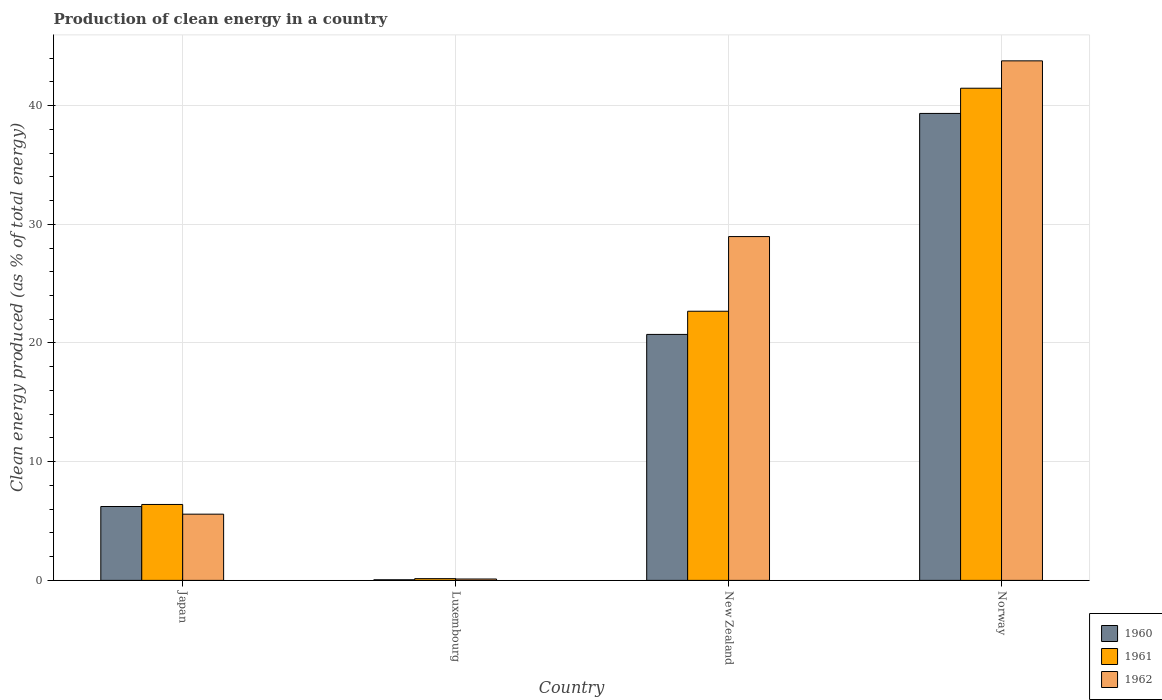Are the number of bars per tick equal to the number of legend labels?
Keep it short and to the point. Yes. Are the number of bars on each tick of the X-axis equal?
Provide a succinct answer. Yes. How many bars are there on the 3rd tick from the left?
Offer a terse response. 3. How many bars are there on the 3rd tick from the right?
Provide a succinct answer. 3. What is the label of the 1st group of bars from the left?
Provide a succinct answer. Japan. What is the percentage of clean energy produced in 1962 in Norway?
Your answer should be compact. 43.77. Across all countries, what is the maximum percentage of clean energy produced in 1961?
Offer a terse response. 41.46. Across all countries, what is the minimum percentage of clean energy produced in 1962?
Your answer should be very brief. 0.12. In which country was the percentage of clean energy produced in 1962 maximum?
Offer a very short reply. Norway. In which country was the percentage of clean energy produced in 1960 minimum?
Provide a short and direct response. Luxembourg. What is the total percentage of clean energy produced in 1961 in the graph?
Provide a short and direct response. 70.68. What is the difference between the percentage of clean energy produced in 1962 in Luxembourg and that in New Zealand?
Provide a succinct answer. -28.85. What is the difference between the percentage of clean energy produced in 1961 in Japan and the percentage of clean energy produced in 1962 in Norway?
Your answer should be compact. -37.37. What is the average percentage of clean energy produced in 1961 per country?
Your response must be concise. 17.67. What is the difference between the percentage of clean energy produced of/in 1960 and percentage of clean energy produced of/in 1962 in Luxembourg?
Provide a succinct answer. -0.06. What is the ratio of the percentage of clean energy produced in 1960 in Luxembourg to that in Norway?
Give a very brief answer. 0. Is the difference between the percentage of clean energy produced in 1960 in Luxembourg and New Zealand greater than the difference between the percentage of clean energy produced in 1962 in Luxembourg and New Zealand?
Keep it short and to the point. Yes. What is the difference between the highest and the second highest percentage of clean energy produced in 1960?
Your response must be concise. 14.5. What is the difference between the highest and the lowest percentage of clean energy produced in 1962?
Keep it short and to the point. 43.65. Is the sum of the percentage of clean energy produced in 1962 in New Zealand and Norway greater than the maximum percentage of clean energy produced in 1960 across all countries?
Keep it short and to the point. Yes. What does the 1st bar from the right in Norway represents?
Your answer should be compact. 1962. How many bars are there?
Offer a terse response. 12. How many countries are there in the graph?
Offer a terse response. 4. Are the values on the major ticks of Y-axis written in scientific E-notation?
Offer a terse response. No. Does the graph contain any zero values?
Give a very brief answer. No. Does the graph contain grids?
Ensure brevity in your answer.  Yes. How many legend labels are there?
Your response must be concise. 3. What is the title of the graph?
Offer a very short reply. Production of clean energy in a country. Does "2010" appear as one of the legend labels in the graph?
Provide a succinct answer. No. What is the label or title of the X-axis?
Ensure brevity in your answer.  Country. What is the label or title of the Y-axis?
Make the answer very short. Clean energy produced (as % of total energy). What is the Clean energy produced (as % of total energy) in 1960 in Japan?
Your answer should be very brief. 6.22. What is the Clean energy produced (as % of total energy) in 1961 in Japan?
Keep it short and to the point. 6.4. What is the Clean energy produced (as % of total energy) in 1962 in Japan?
Offer a very short reply. 5.58. What is the Clean energy produced (as % of total energy) of 1960 in Luxembourg?
Give a very brief answer. 0.05. What is the Clean energy produced (as % of total energy) of 1961 in Luxembourg?
Provide a short and direct response. 0.15. What is the Clean energy produced (as % of total energy) of 1962 in Luxembourg?
Your response must be concise. 0.12. What is the Clean energy produced (as % of total energy) in 1960 in New Zealand?
Your response must be concise. 20.72. What is the Clean energy produced (as % of total energy) in 1961 in New Zealand?
Offer a terse response. 22.67. What is the Clean energy produced (as % of total energy) of 1962 in New Zealand?
Keep it short and to the point. 28.96. What is the Clean energy produced (as % of total energy) in 1960 in Norway?
Ensure brevity in your answer.  39.34. What is the Clean energy produced (as % of total energy) in 1961 in Norway?
Keep it short and to the point. 41.46. What is the Clean energy produced (as % of total energy) in 1962 in Norway?
Ensure brevity in your answer.  43.77. Across all countries, what is the maximum Clean energy produced (as % of total energy) of 1960?
Your answer should be compact. 39.34. Across all countries, what is the maximum Clean energy produced (as % of total energy) of 1961?
Offer a very short reply. 41.46. Across all countries, what is the maximum Clean energy produced (as % of total energy) in 1962?
Provide a succinct answer. 43.77. Across all countries, what is the minimum Clean energy produced (as % of total energy) of 1960?
Provide a short and direct response. 0.05. Across all countries, what is the minimum Clean energy produced (as % of total energy) of 1961?
Provide a succinct answer. 0.15. Across all countries, what is the minimum Clean energy produced (as % of total energy) of 1962?
Your answer should be compact. 0.12. What is the total Clean energy produced (as % of total energy) of 1960 in the graph?
Your response must be concise. 66.33. What is the total Clean energy produced (as % of total energy) of 1961 in the graph?
Your answer should be compact. 70.68. What is the total Clean energy produced (as % of total energy) in 1962 in the graph?
Your answer should be compact. 78.42. What is the difference between the Clean energy produced (as % of total energy) of 1960 in Japan and that in Luxembourg?
Your response must be concise. 6.17. What is the difference between the Clean energy produced (as % of total energy) of 1961 in Japan and that in Luxembourg?
Provide a succinct answer. 6.25. What is the difference between the Clean energy produced (as % of total energy) of 1962 in Japan and that in Luxembourg?
Keep it short and to the point. 5.46. What is the difference between the Clean energy produced (as % of total energy) of 1960 in Japan and that in New Zealand?
Your response must be concise. -14.5. What is the difference between the Clean energy produced (as % of total energy) in 1961 in Japan and that in New Zealand?
Your answer should be very brief. -16.28. What is the difference between the Clean energy produced (as % of total energy) in 1962 in Japan and that in New Zealand?
Keep it short and to the point. -23.38. What is the difference between the Clean energy produced (as % of total energy) in 1960 in Japan and that in Norway?
Keep it short and to the point. -33.11. What is the difference between the Clean energy produced (as % of total energy) in 1961 in Japan and that in Norway?
Offer a very short reply. -35.06. What is the difference between the Clean energy produced (as % of total energy) of 1962 in Japan and that in Norway?
Offer a terse response. -38.19. What is the difference between the Clean energy produced (as % of total energy) in 1960 in Luxembourg and that in New Zealand?
Your answer should be compact. -20.67. What is the difference between the Clean energy produced (as % of total energy) in 1961 in Luxembourg and that in New Zealand?
Provide a succinct answer. -22.53. What is the difference between the Clean energy produced (as % of total energy) in 1962 in Luxembourg and that in New Zealand?
Your answer should be compact. -28.85. What is the difference between the Clean energy produced (as % of total energy) in 1960 in Luxembourg and that in Norway?
Offer a terse response. -39.28. What is the difference between the Clean energy produced (as % of total energy) in 1961 in Luxembourg and that in Norway?
Provide a succinct answer. -41.31. What is the difference between the Clean energy produced (as % of total energy) of 1962 in Luxembourg and that in Norway?
Your answer should be very brief. -43.65. What is the difference between the Clean energy produced (as % of total energy) in 1960 in New Zealand and that in Norway?
Keep it short and to the point. -18.62. What is the difference between the Clean energy produced (as % of total energy) in 1961 in New Zealand and that in Norway?
Your response must be concise. -18.79. What is the difference between the Clean energy produced (as % of total energy) in 1962 in New Zealand and that in Norway?
Your answer should be very brief. -14.8. What is the difference between the Clean energy produced (as % of total energy) in 1960 in Japan and the Clean energy produced (as % of total energy) in 1961 in Luxembourg?
Make the answer very short. 6.08. What is the difference between the Clean energy produced (as % of total energy) of 1960 in Japan and the Clean energy produced (as % of total energy) of 1962 in Luxembourg?
Your answer should be very brief. 6.11. What is the difference between the Clean energy produced (as % of total energy) in 1961 in Japan and the Clean energy produced (as % of total energy) in 1962 in Luxembourg?
Provide a succinct answer. 6.28. What is the difference between the Clean energy produced (as % of total energy) of 1960 in Japan and the Clean energy produced (as % of total energy) of 1961 in New Zealand?
Provide a succinct answer. -16.45. What is the difference between the Clean energy produced (as % of total energy) in 1960 in Japan and the Clean energy produced (as % of total energy) in 1962 in New Zealand?
Keep it short and to the point. -22.74. What is the difference between the Clean energy produced (as % of total energy) of 1961 in Japan and the Clean energy produced (as % of total energy) of 1962 in New Zealand?
Give a very brief answer. -22.57. What is the difference between the Clean energy produced (as % of total energy) in 1960 in Japan and the Clean energy produced (as % of total energy) in 1961 in Norway?
Offer a terse response. -35.24. What is the difference between the Clean energy produced (as % of total energy) of 1960 in Japan and the Clean energy produced (as % of total energy) of 1962 in Norway?
Provide a succinct answer. -37.54. What is the difference between the Clean energy produced (as % of total energy) of 1961 in Japan and the Clean energy produced (as % of total energy) of 1962 in Norway?
Your answer should be compact. -37.37. What is the difference between the Clean energy produced (as % of total energy) of 1960 in Luxembourg and the Clean energy produced (as % of total energy) of 1961 in New Zealand?
Provide a short and direct response. -22.62. What is the difference between the Clean energy produced (as % of total energy) in 1960 in Luxembourg and the Clean energy produced (as % of total energy) in 1962 in New Zealand?
Make the answer very short. -28.91. What is the difference between the Clean energy produced (as % of total energy) of 1961 in Luxembourg and the Clean energy produced (as % of total energy) of 1962 in New Zealand?
Offer a terse response. -28.82. What is the difference between the Clean energy produced (as % of total energy) of 1960 in Luxembourg and the Clean energy produced (as % of total energy) of 1961 in Norway?
Your answer should be compact. -41.41. What is the difference between the Clean energy produced (as % of total energy) of 1960 in Luxembourg and the Clean energy produced (as % of total energy) of 1962 in Norway?
Ensure brevity in your answer.  -43.71. What is the difference between the Clean energy produced (as % of total energy) in 1961 in Luxembourg and the Clean energy produced (as % of total energy) in 1962 in Norway?
Your answer should be very brief. -43.62. What is the difference between the Clean energy produced (as % of total energy) of 1960 in New Zealand and the Clean energy produced (as % of total energy) of 1961 in Norway?
Give a very brief answer. -20.74. What is the difference between the Clean energy produced (as % of total energy) in 1960 in New Zealand and the Clean energy produced (as % of total energy) in 1962 in Norway?
Offer a terse response. -23.05. What is the difference between the Clean energy produced (as % of total energy) of 1961 in New Zealand and the Clean energy produced (as % of total energy) of 1962 in Norway?
Give a very brief answer. -21.09. What is the average Clean energy produced (as % of total energy) in 1960 per country?
Provide a short and direct response. 16.58. What is the average Clean energy produced (as % of total energy) in 1961 per country?
Offer a terse response. 17.67. What is the average Clean energy produced (as % of total energy) of 1962 per country?
Your answer should be compact. 19.61. What is the difference between the Clean energy produced (as % of total energy) in 1960 and Clean energy produced (as % of total energy) in 1961 in Japan?
Make the answer very short. -0.17. What is the difference between the Clean energy produced (as % of total energy) in 1960 and Clean energy produced (as % of total energy) in 1962 in Japan?
Offer a very short reply. 0.64. What is the difference between the Clean energy produced (as % of total energy) of 1961 and Clean energy produced (as % of total energy) of 1962 in Japan?
Offer a terse response. 0.82. What is the difference between the Clean energy produced (as % of total energy) in 1960 and Clean energy produced (as % of total energy) in 1961 in Luxembourg?
Ensure brevity in your answer.  -0.09. What is the difference between the Clean energy produced (as % of total energy) of 1960 and Clean energy produced (as % of total energy) of 1962 in Luxembourg?
Provide a short and direct response. -0.06. What is the difference between the Clean energy produced (as % of total energy) of 1961 and Clean energy produced (as % of total energy) of 1962 in Luxembourg?
Your answer should be compact. 0.03. What is the difference between the Clean energy produced (as % of total energy) of 1960 and Clean energy produced (as % of total energy) of 1961 in New Zealand?
Provide a short and direct response. -1.95. What is the difference between the Clean energy produced (as % of total energy) of 1960 and Clean energy produced (as % of total energy) of 1962 in New Zealand?
Your answer should be very brief. -8.24. What is the difference between the Clean energy produced (as % of total energy) of 1961 and Clean energy produced (as % of total energy) of 1962 in New Zealand?
Make the answer very short. -6.29. What is the difference between the Clean energy produced (as % of total energy) of 1960 and Clean energy produced (as % of total energy) of 1961 in Norway?
Keep it short and to the point. -2.12. What is the difference between the Clean energy produced (as % of total energy) in 1960 and Clean energy produced (as % of total energy) in 1962 in Norway?
Ensure brevity in your answer.  -4.43. What is the difference between the Clean energy produced (as % of total energy) in 1961 and Clean energy produced (as % of total energy) in 1962 in Norway?
Your response must be concise. -2.31. What is the ratio of the Clean energy produced (as % of total energy) of 1960 in Japan to that in Luxembourg?
Offer a terse response. 119.55. What is the ratio of the Clean energy produced (as % of total energy) of 1961 in Japan to that in Luxembourg?
Your response must be concise. 43.55. What is the ratio of the Clean energy produced (as % of total energy) of 1962 in Japan to that in Luxembourg?
Give a very brief answer. 48.16. What is the ratio of the Clean energy produced (as % of total energy) of 1960 in Japan to that in New Zealand?
Your response must be concise. 0.3. What is the ratio of the Clean energy produced (as % of total energy) in 1961 in Japan to that in New Zealand?
Keep it short and to the point. 0.28. What is the ratio of the Clean energy produced (as % of total energy) of 1962 in Japan to that in New Zealand?
Offer a very short reply. 0.19. What is the ratio of the Clean energy produced (as % of total energy) in 1960 in Japan to that in Norway?
Give a very brief answer. 0.16. What is the ratio of the Clean energy produced (as % of total energy) of 1961 in Japan to that in Norway?
Your answer should be very brief. 0.15. What is the ratio of the Clean energy produced (as % of total energy) in 1962 in Japan to that in Norway?
Give a very brief answer. 0.13. What is the ratio of the Clean energy produced (as % of total energy) in 1960 in Luxembourg to that in New Zealand?
Keep it short and to the point. 0. What is the ratio of the Clean energy produced (as % of total energy) of 1961 in Luxembourg to that in New Zealand?
Offer a terse response. 0.01. What is the ratio of the Clean energy produced (as % of total energy) of 1962 in Luxembourg to that in New Zealand?
Make the answer very short. 0. What is the ratio of the Clean energy produced (as % of total energy) of 1960 in Luxembourg to that in Norway?
Your answer should be compact. 0. What is the ratio of the Clean energy produced (as % of total energy) of 1961 in Luxembourg to that in Norway?
Provide a succinct answer. 0. What is the ratio of the Clean energy produced (as % of total energy) of 1962 in Luxembourg to that in Norway?
Keep it short and to the point. 0. What is the ratio of the Clean energy produced (as % of total energy) in 1960 in New Zealand to that in Norway?
Keep it short and to the point. 0.53. What is the ratio of the Clean energy produced (as % of total energy) in 1961 in New Zealand to that in Norway?
Provide a short and direct response. 0.55. What is the ratio of the Clean energy produced (as % of total energy) of 1962 in New Zealand to that in Norway?
Provide a short and direct response. 0.66. What is the difference between the highest and the second highest Clean energy produced (as % of total energy) of 1960?
Your answer should be compact. 18.62. What is the difference between the highest and the second highest Clean energy produced (as % of total energy) in 1961?
Your answer should be compact. 18.79. What is the difference between the highest and the second highest Clean energy produced (as % of total energy) in 1962?
Give a very brief answer. 14.8. What is the difference between the highest and the lowest Clean energy produced (as % of total energy) of 1960?
Your answer should be very brief. 39.28. What is the difference between the highest and the lowest Clean energy produced (as % of total energy) of 1961?
Your answer should be compact. 41.31. What is the difference between the highest and the lowest Clean energy produced (as % of total energy) of 1962?
Offer a terse response. 43.65. 